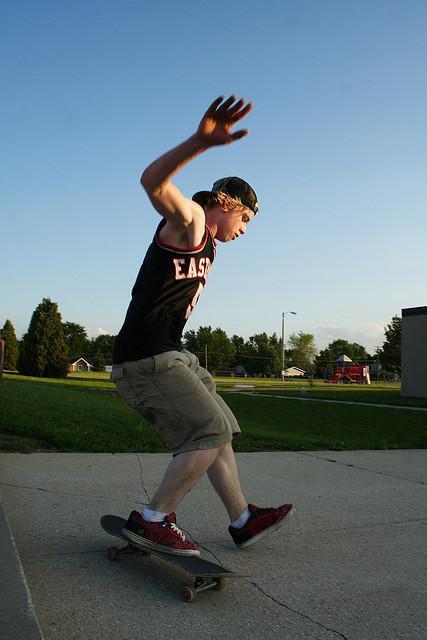How many arms does he have?
Give a very brief answer. 2. 